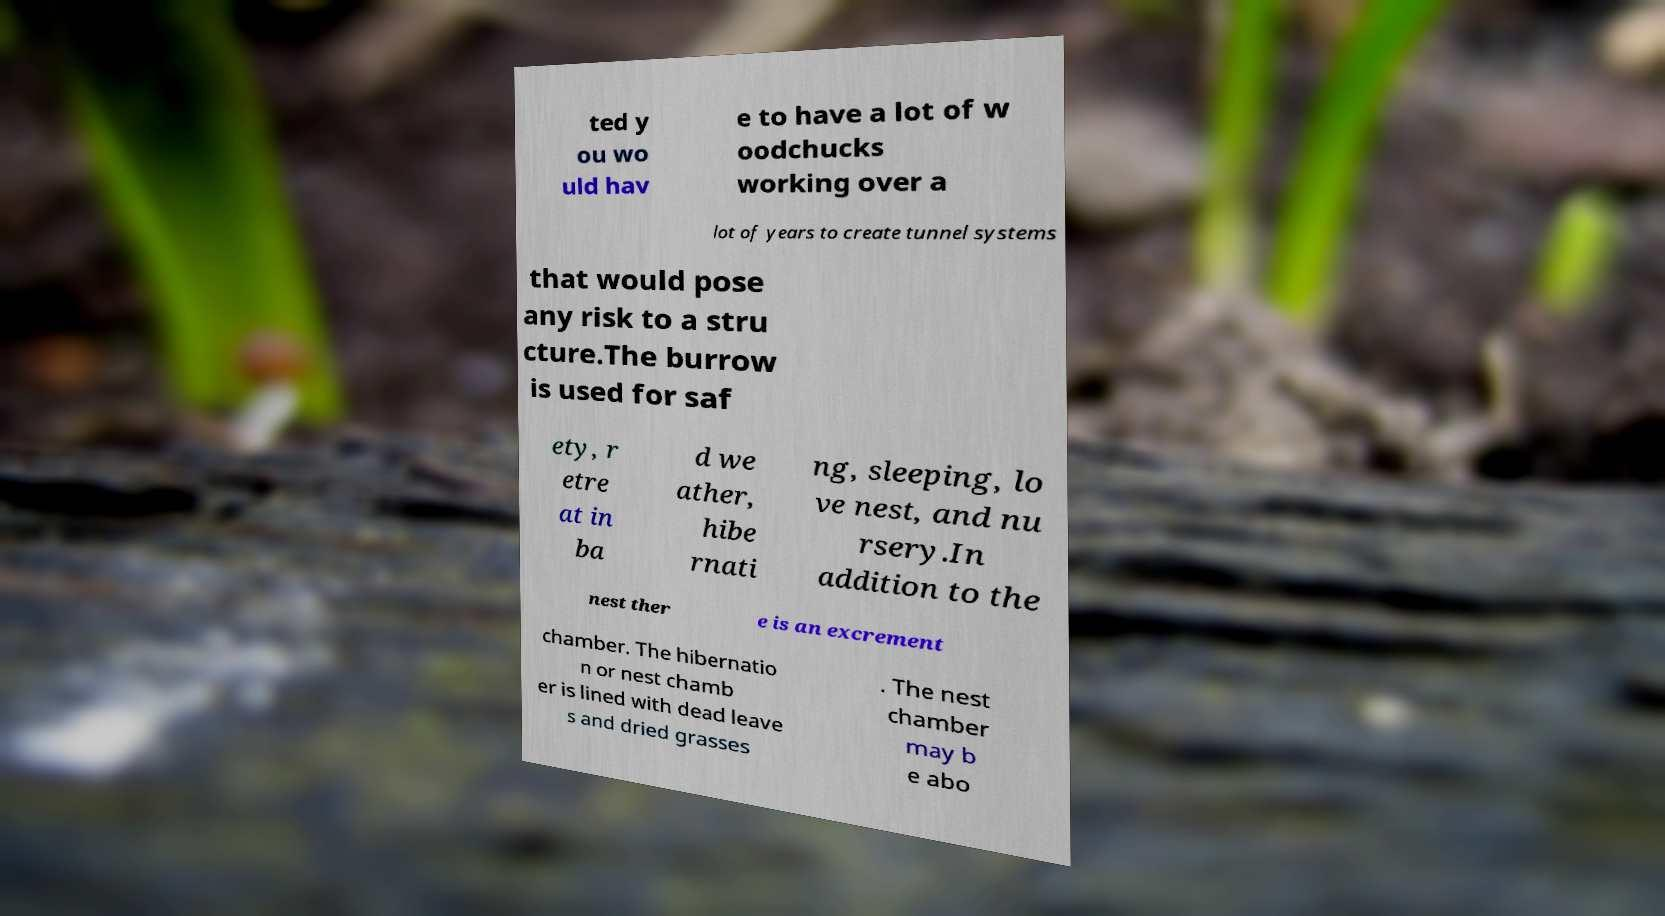Could you assist in decoding the text presented in this image and type it out clearly? ted y ou wo uld hav e to have a lot of w oodchucks working over a lot of years to create tunnel systems that would pose any risk to a stru cture.The burrow is used for saf ety, r etre at in ba d we ather, hibe rnati ng, sleeping, lo ve nest, and nu rsery.In addition to the nest ther e is an excrement chamber. The hibernatio n or nest chamb er is lined with dead leave s and dried grasses . The nest chamber may b e abo 